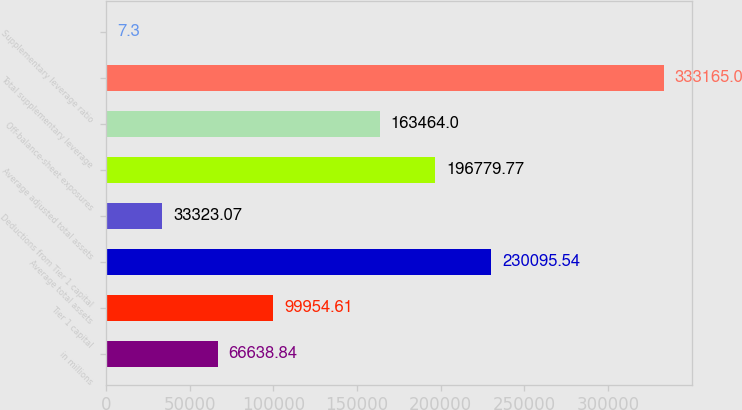Convert chart to OTSL. <chart><loc_0><loc_0><loc_500><loc_500><bar_chart><fcel>in millions<fcel>Tier 1 capital<fcel>Average total assets<fcel>Deductions from Tier 1 capital<fcel>Average adjusted total assets<fcel>Off-balance-sheet exposures<fcel>Total supplementary leverage<fcel>Supplementary leverage ratio<nl><fcel>66638.8<fcel>99954.6<fcel>230096<fcel>33323.1<fcel>196780<fcel>163464<fcel>333165<fcel>7.3<nl></chart> 